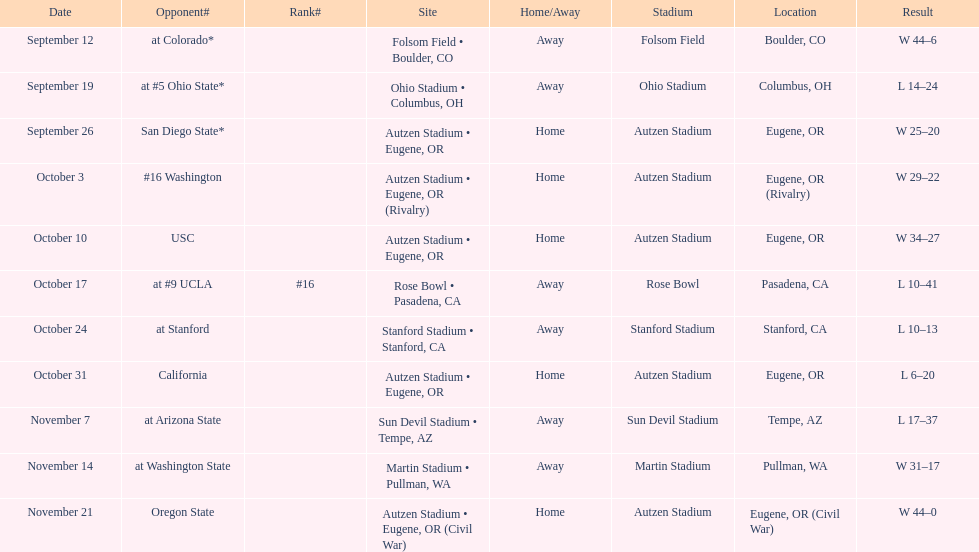Were the results of the game of november 14 above or below the results of the october 17 game? Above. 